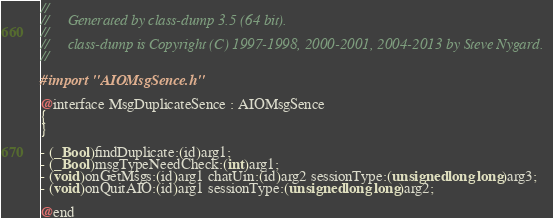<code> <loc_0><loc_0><loc_500><loc_500><_C_>//
//     Generated by class-dump 3.5 (64 bit).
//
//     class-dump is Copyright (C) 1997-1998, 2000-2001, 2004-2013 by Steve Nygard.
//

#import "AIOMsgSence.h"

@interface MsgDuplicateSence : AIOMsgSence
{
}

- (_Bool)findDuplicate:(id)arg1;
- (_Bool)msgTypeNeedCheck:(int)arg1;
- (void)onGetMsgs:(id)arg1 chatUin:(id)arg2 sessionType:(unsigned long long)arg3;
- (void)onQuitAIO:(id)arg1 sessionType:(unsigned long long)arg2;

@end

</code> 